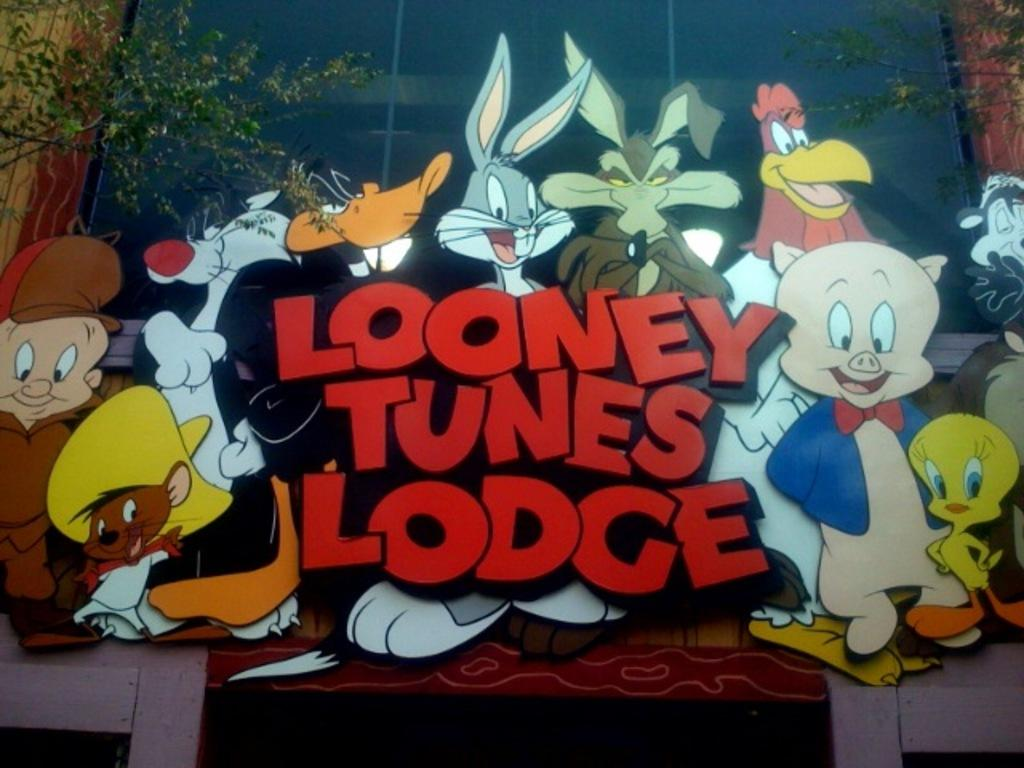What type of characters can be seen in the image? There are cartoon characters in the image. Where is the tree located in the image? The tree is on the left side of the image. What structure is in the middle of the image? There is a glass wall of a building in the middle of the image. How many mice are sleeping on the tree in the image? There are no mice present in the image, and they are not sleeping on the tree. What type of ticket can be seen in the image? There is no ticket present in the image. 